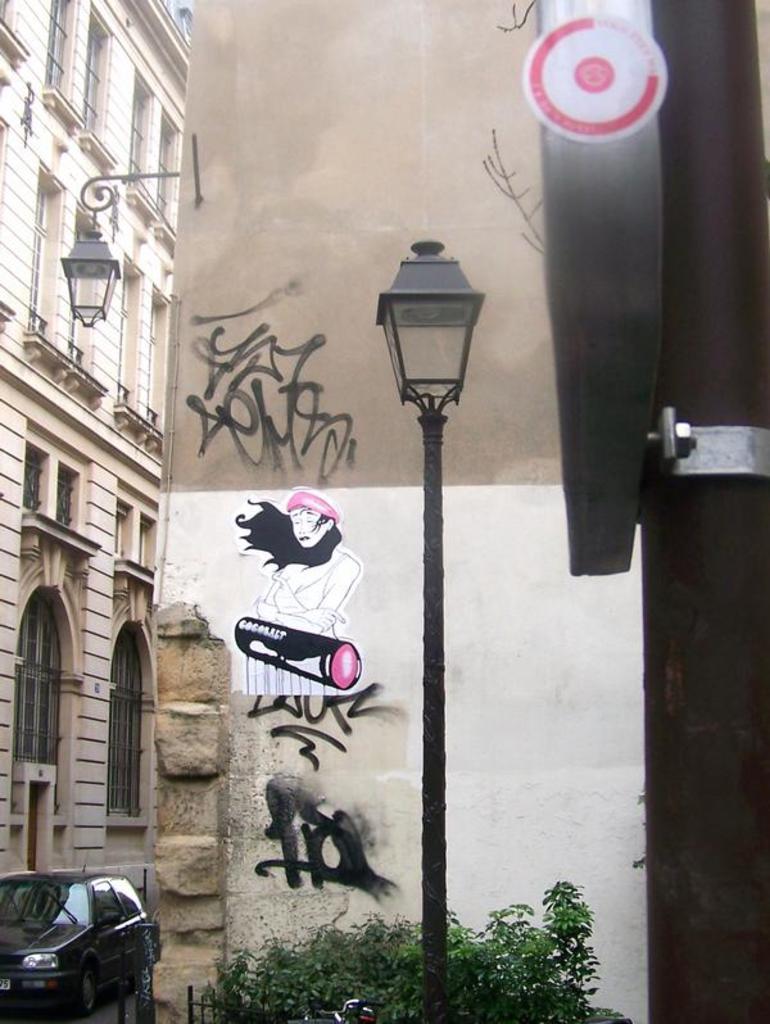Could you give a brief overview of what you see in this image? In the foreground of the picture there are pole, street light, plants and a wall. On the left there are building, street light and a car. 